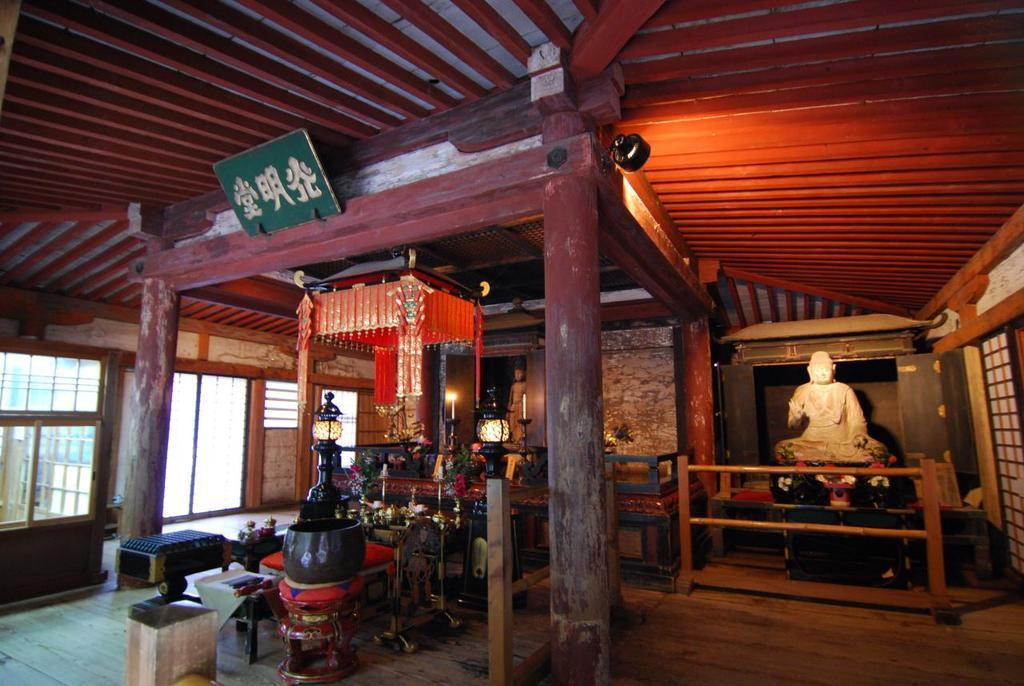What architectural features can be seen in the image? There are pillars in the image. What type of decorative elements are present in the image? There are statues in the image. What structure covers the area in the image? There is a roof in the image. Can you describe any other objects in the image? There are some unspecified objects in the image. What type of pollution can be seen in the image? There is no pollution visible in the image. What type of screw is used to hold the brass in place in the image? There is no brass or screws present in the image. 